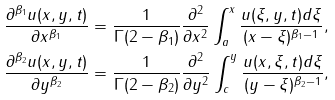<formula> <loc_0><loc_0><loc_500><loc_500>\frac { \partial ^ { \beta _ { 1 } } u ( x , y , t ) } { \partial x ^ { \beta _ { 1 } } } & = \frac { 1 } { \Gamma ( 2 - \beta _ { 1 } ) } \frac { \partial ^ { 2 } } { \partial x ^ { 2 } } \int ^ { x } _ { a } \frac { u ( \xi , y , t ) d \xi } { ( x - \xi ) ^ { \beta _ { 1 } - 1 } } , \\ \frac { \partial ^ { \beta _ { 2 } } u ( x , y , t ) } { \partial y ^ { \beta _ { 2 } } } & = \frac { 1 } { \Gamma ( 2 - \beta _ { 2 } ) } \frac { \partial ^ { 2 } } { \partial y ^ { 2 } } \int ^ { y } _ { c } \frac { u ( x , \xi , t ) d \xi } { ( y - \xi ) ^ { \beta _ { 2 } - 1 } } ,</formula> 